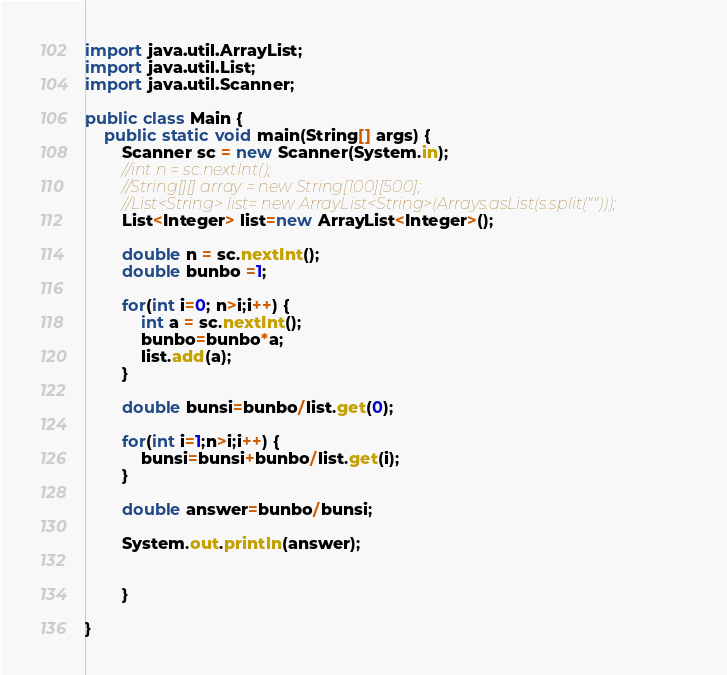Convert code to text. <code><loc_0><loc_0><loc_500><loc_500><_Java_>import java.util.ArrayList;
import java.util.List;
import java.util.Scanner;

public class Main {
	public static void main(String[] args) {
		Scanner sc = new Scanner(System.in);
		//int n = sc.nextInt();
		//String[][] array = new String[100][500];
		//List<String> list= new ArrayList<String>(Arrays.asList(s.split("")));
		List<Integer> list=new ArrayList<Integer>();

		double n = sc.nextInt();
		double bunbo =1;

		for(int i=0; n>i;i++) {
			int a = sc.nextInt();
			bunbo=bunbo*a;
			list.add(a);
		}

		double bunsi=bunbo/list.get(0);

		for(int i=1;n>i;i++) {
			bunsi=bunsi+bunbo/list.get(i);
		}

		double answer=bunbo/bunsi;

		System.out.println(answer);


		}

}</code> 